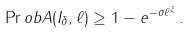<formula> <loc_0><loc_0><loc_500><loc_500>\Pr o b { A ( I _ { \delta } , \ell ) } \geq 1 - e ^ { - \sigma \ell ^ { \xi } } \, .</formula> 